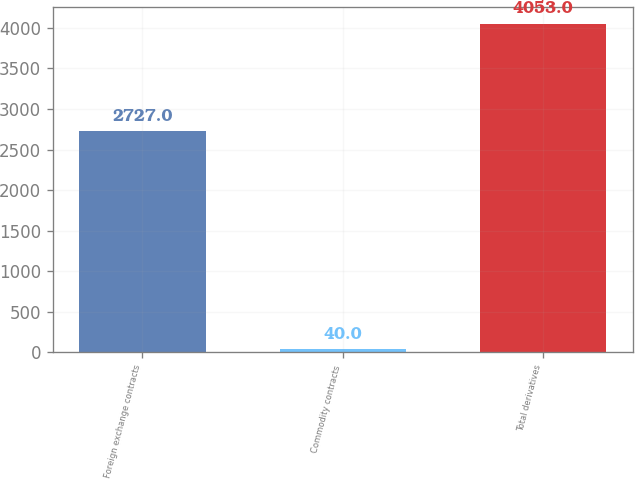Convert chart to OTSL. <chart><loc_0><loc_0><loc_500><loc_500><bar_chart><fcel>Foreign exchange contracts<fcel>Commodity contracts<fcel>Total derivatives<nl><fcel>2727<fcel>40<fcel>4053<nl></chart> 